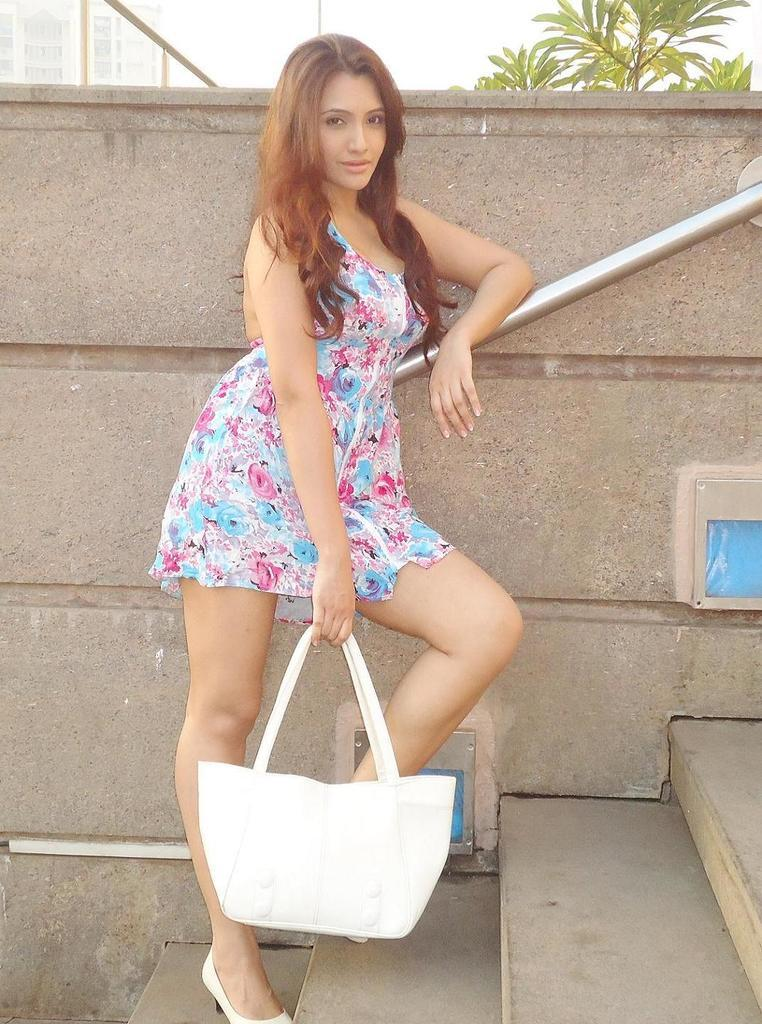Who or what is present in the image? There is a person in the image. What is the person holding in the image? The person is holding a bag. What can be seen in the background of the image? There is a plant in the background of the image. How many kittens are playing with the bag in the image? There are no kittens present in the image, and therefore no such activity can be observed. 